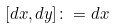<formula> <loc_0><loc_0><loc_500><loc_500>[ d x , d y ] \colon = d x</formula> 